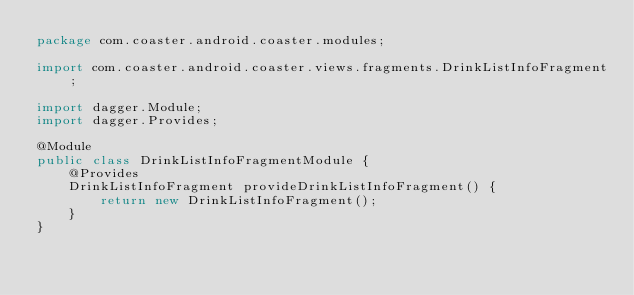<code> <loc_0><loc_0><loc_500><loc_500><_Java_>package com.coaster.android.coaster.modules;

import com.coaster.android.coaster.views.fragments.DrinkListInfoFragment;

import dagger.Module;
import dagger.Provides;

@Module
public class DrinkListInfoFragmentModule {
    @Provides
    DrinkListInfoFragment provideDrinkListInfoFragment() {
        return new DrinkListInfoFragment();
    }
}
</code> 